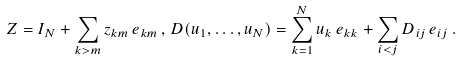Convert formula to latex. <formula><loc_0><loc_0><loc_500><loc_500>Z = I _ { N } + \sum _ { k > m } z _ { k m } \, e _ { k m } \, , \, D ( u _ { 1 } , \dots , u _ { N } ) = \sum _ { k = 1 } ^ { N } u _ { k } \, e _ { k k } + \sum _ { i < j } D _ { i j } \, e _ { i j } \, .</formula> 